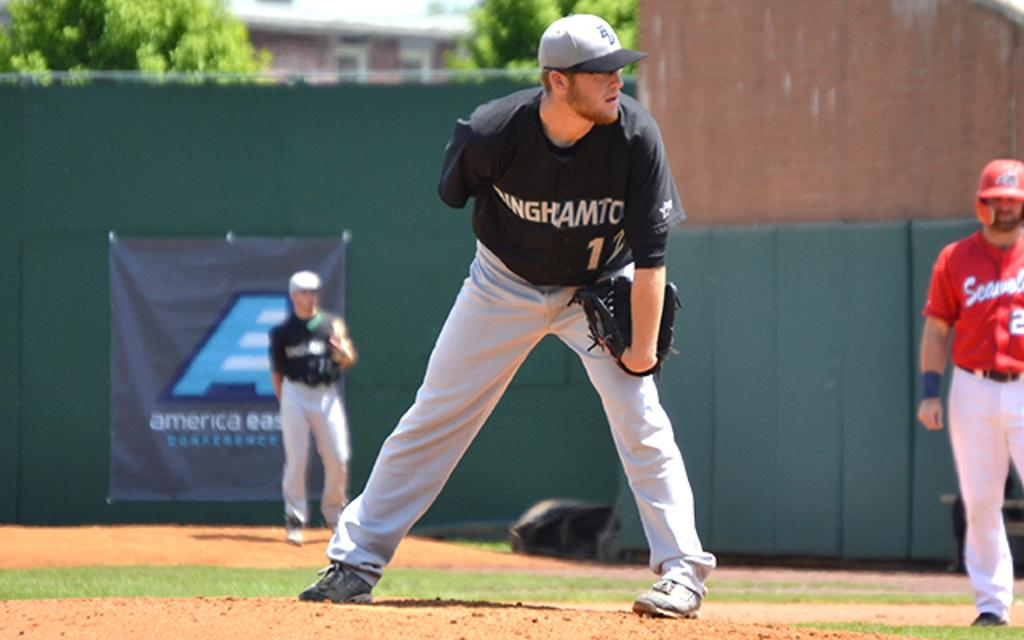<image>
Offer a succinct explanation of the picture presented. a sign in the outfield has the word America on it 